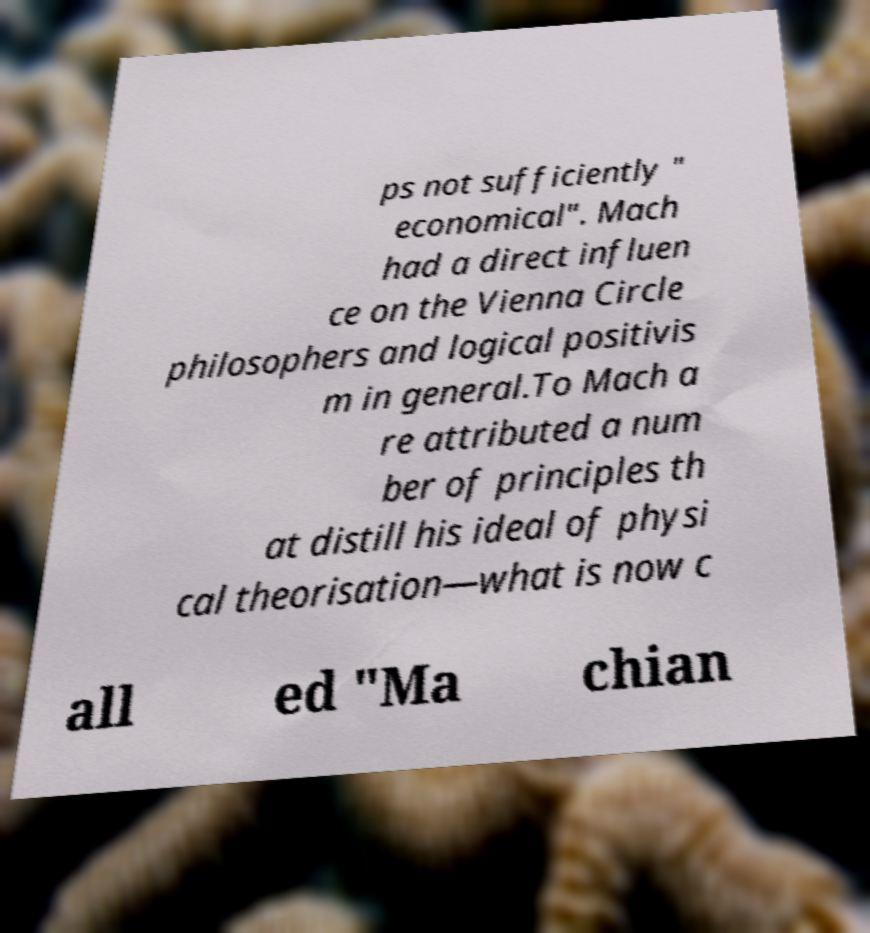There's text embedded in this image that I need extracted. Can you transcribe it verbatim? ps not sufficiently " economical". Mach had a direct influen ce on the Vienna Circle philosophers and logical positivis m in general.To Mach a re attributed a num ber of principles th at distill his ideal of physi cal theorisation—what is now c all ed "Ma chian 